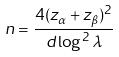Convert formula to latex. <formula><loc_0><loc_0><loc_500><loc_500>n = \frac { 4 ( z _ { \alpha } + z _ { \beta } ) ^ { 2 } } { d \log ^ { 2 } \lambda }</formula> 